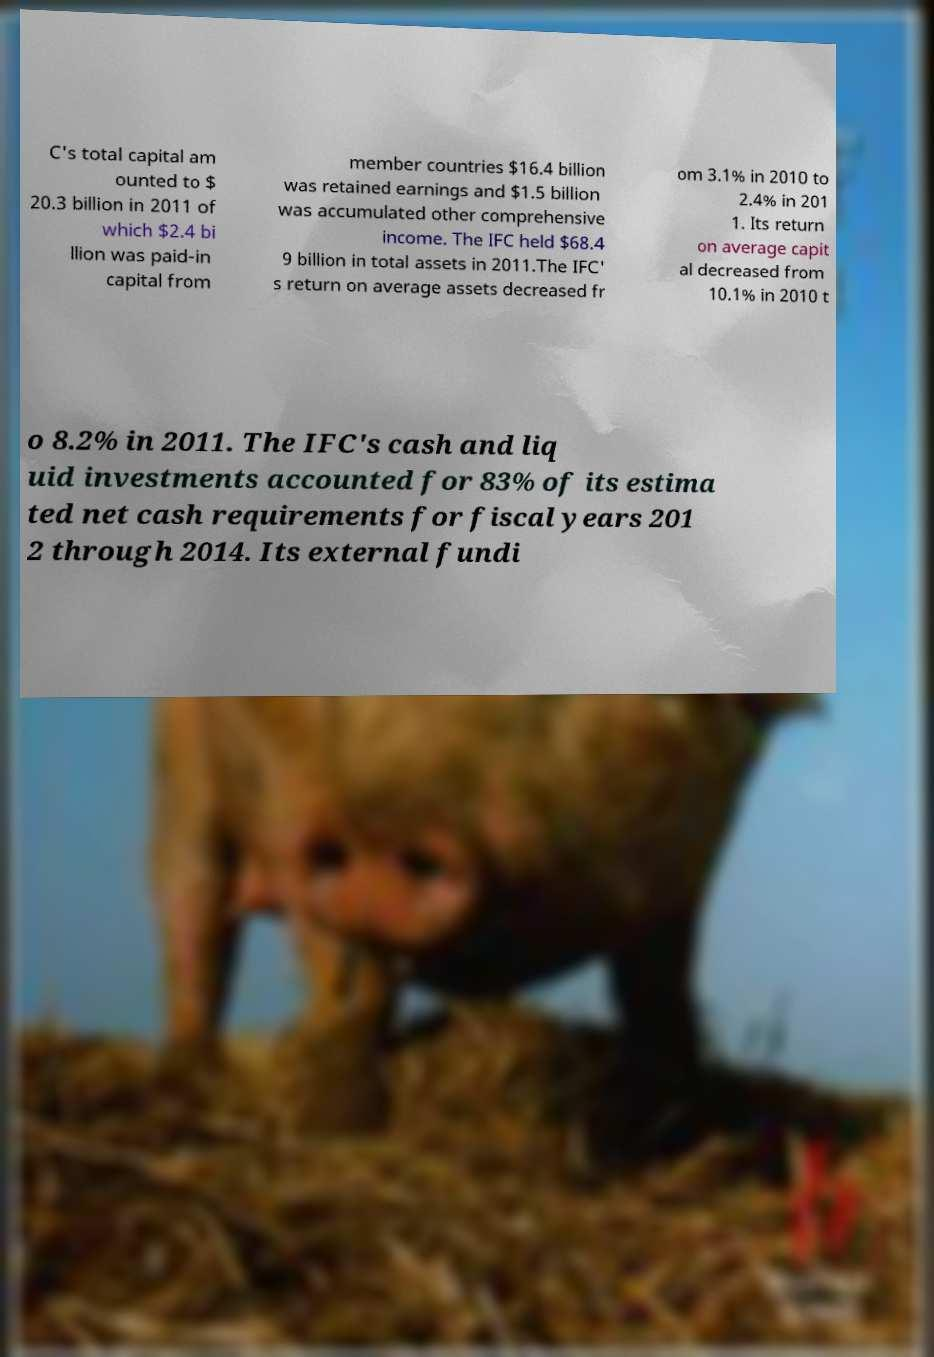What messages or text are displayed in this image? I need them in a readable, typed format. C's total capital am ounted to $ 20.3 billion in 2011 of which $2.4 bi llion was paid-in capital from member countries $16.4 billion was retained earnings and $1.5 billion was accumulated other comprehensive income. The IFC held $68.4 9 billion in total assets in 2011.The IFC' s return on average assets decreased fr om 3.1% in 2010 to 2.4% in 201 1. Its return on average capit al decreased from 10.1% in 2010 t o 8.2% in 2011. The IFC's cash and liq uid investments accounted for 83% of its estima ted net cash requirements for fiscal years 201 2 through 2014. Its external fundi 